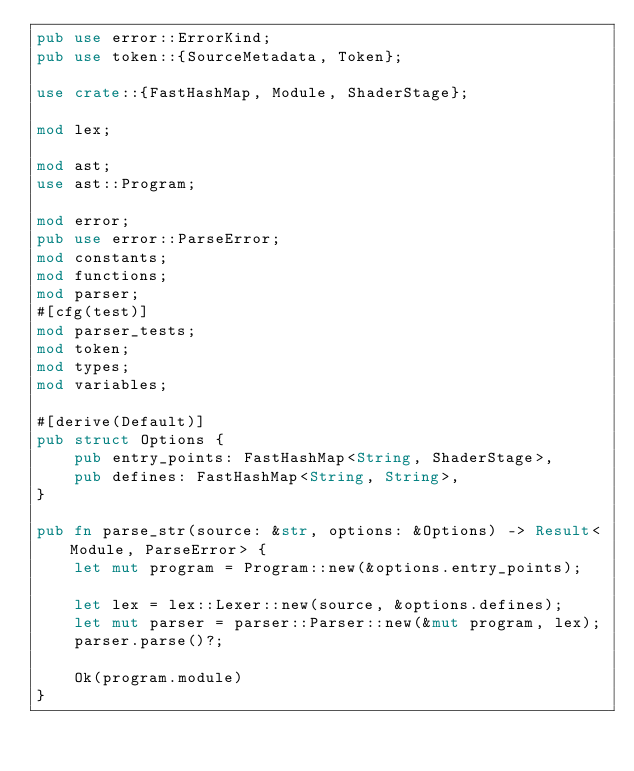Convert code to text. <code><loc_0><loc_0><loc_500><loc_500><_Rust_>pub use error::ErrorKind;
pub use token::{SourceMetadata, Token};

use crate::{FastHashMap, Module, ShaderStage};

mod lex;

mod ast;
use ast::Program;

mod error;
pub use error::ParseError;
mod constants;
mod functions;
mod parser;
#[cfg(test)]
mod parser_tests;
mod token;
mod types;
mod variables;

#[derive(Default)]
pub struct Options {
    pub entry_points: FastHashMap<String, ShaderStage>,
    pub defines: FastHashMap<String, String>,
}

pub fn parse_str(source: &str, options: &Options) -> Result<Module, ParseError> {
    let mut program = Program::new(&options.entry_points);

    let lex = lex::Lexer::new(source, &options.defines);
    let mut parser = parser::Parser::new(&mut program, lex);
    parser.parse()?;

    Ok(program.module)
}
</code> 